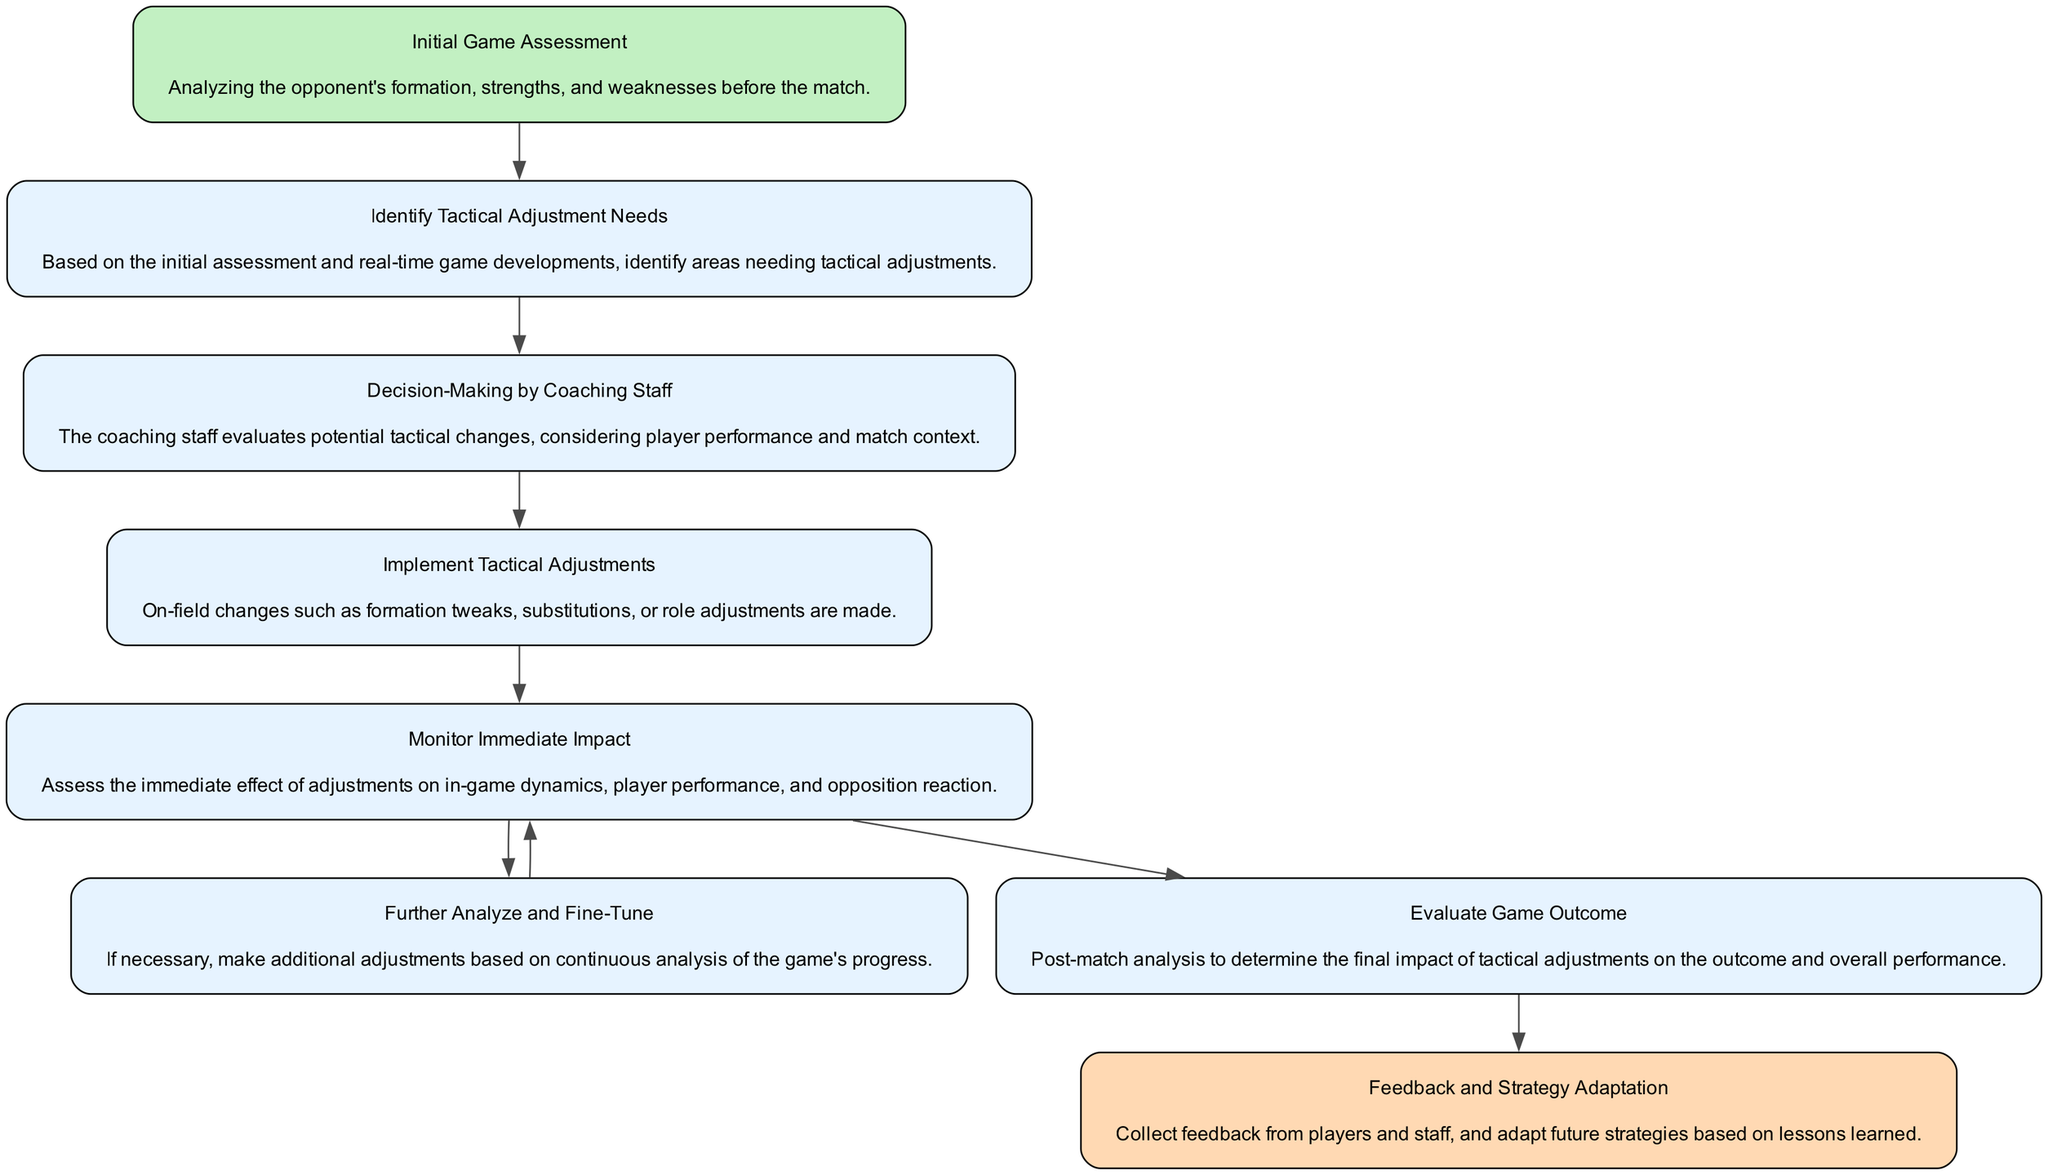What is the first step in the workflow? The diagram clearly designates "Initial Game Assessment" as the starting point of the workflow, as it flows from this starting node first according to the structure of the diagram.
Answer: Initial Game Assessment How many steps are there in total? By counting the nodes in the diagram, there are eight distinct steps, which includes all the nodes presented in the workflow.
Answer: 8 What step follows "Monitor Immediate Impact"? The diagram indicates that "Monitor Immediate Impact" can lead to two next steps: "Further Analyze and Fine-Tune" and "Evaluate Game Outcome." However, "Evaluate Game Outcome" is uniquely listed in a consecutive and singular context following the action of monitoring.
Answer: Evaluate Game Outcome What is the outcome of the "Feedback and Strategy Adaptation" step? According to the structure, the outcome leads back to "Initial Game Assessment," indicating a loop back to the beginning of the assessment process.
Answer: Initial Game Assessment Which step involves on-field changes? The "Implement Tactical Adjustments" step is explicitly defined as involving the changes made on the field, such as tweaks to formation or substitutions based on the analysis done.
Answer: Implement Tactical Adjustments Which elements need to be evaluated collectively for further analysis? After "Monitor Immediate Impact," if further adjustments are needed, it leads to "Further Analyze and Fine-Tune," which would require a collective evaluation of the immediate impact alongside game progression for effective tactical changes.
Answer: Further Analyze and Fine-Tune How many distinct outcomes does "Monitor Immediate Impact" lead to? The diagram shows that "Monitor Immediate Impact" can result in two distinct next steps, leading to further actions in the workflow.
Answer: 2 What is the primary focus during the "Decision-Making by Coaching Staff"? The primary focus is on evaluating potential tactical changes by considering player performance and the context of the match, which is described in the step's description.
Answer: Evaluating potential tactical changes What is the last step in the workflow before the process starts over? The last step in the workflow, which leads back to the start, is "Feedback and Strategy Adaptation," where feedback is collected and future strategies are adapted based on insights gained.
Answer: Feedback and Strategy Adaptation 